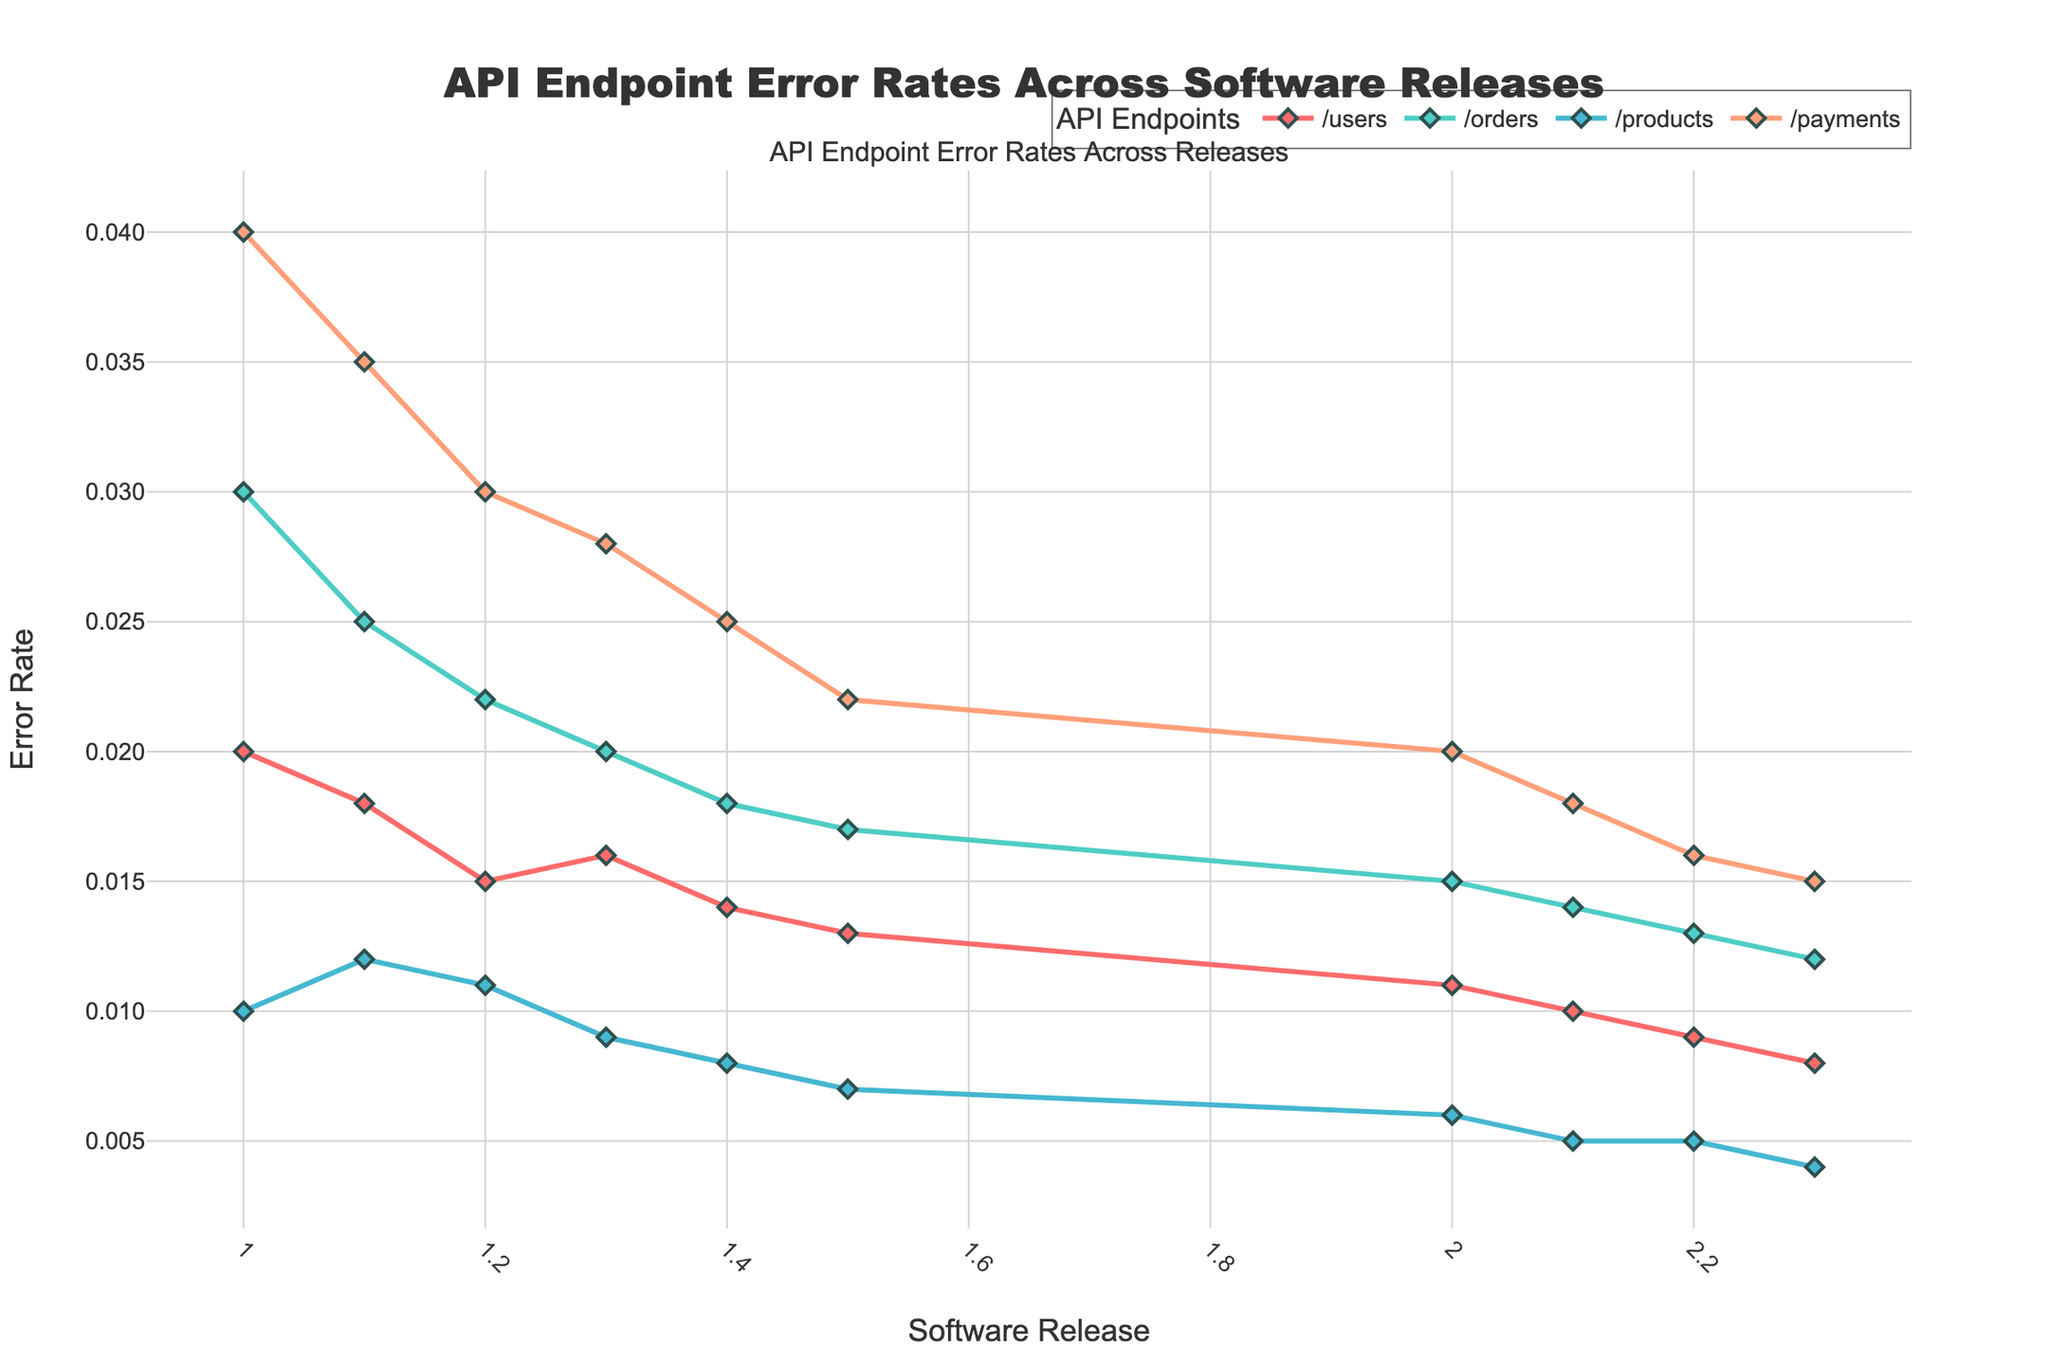Which API endpoint showed the highest error rate in release 1.0? Look at the error rates for /users, /orders, /products, and /payments in release 1.0. The /payments endpoint has the highest error rate of 0.04.
Answer: /payments Which API endpoint has the lowest error rate across all releases? Compare the lowest error rates for each endpoint across releases. The /products endpoint has the minimum error rate of 0.004 in release 2.3.
Answer: /products Between releases 1.0 and 2.3, which API endpoint had the largest decrease in error rate? Compare the error rates for each endpoint in releases 1.0 and 2.3. /payments had an error rate decrease from 0.04 in release 1.0 to 0.015 in release 2.3, a decrease of 0.025.
Answer: /payments In which release did the /orders API endpoint first achieve an error rate of 0.02 or lower? Look at the error rates for the /orders endpoint across all releases. It first achieved an error rate of 0.02 in release 1.3.
Answer: 1.3 How many software releases had an error rate of less than 0.01 for the /products API endpoint? Count the releases where the /products endpoint had an error rate less than 0.01. These are releases 1.4, 1.5, 2.0, 2.1, 2.2, 2.3. Six releases in total.
Answer: 6 What is the average error rate for the /users endpoint across all releases? Sum the error rates for the /users endpoint across all releases and divide by the number of releases: (0.02 + 0.018 + 0.015 + 0.016 + 0.014 + 0.013 + 0.011 + 0.01 + 0.009 + 0.008) / 10 = 0.0134.
Answer: 0.0134 Which release shows the smallest variation in error rates across all API endpoints? Calculate the range (max error rate - min error rate) for each release. Release 2.3 has the smallest range: 0.008 (/users) - 0.004 (/products) = 0.004.
Answer: 2.3 By how much did the error rate of the /orders endpoint improve from release 1.1 to release 2.1? The error rate for the /orders endpoint in release 1.1 is 0.025, and in release 2.1 it is 0.014. The improvement is 0.025 - 0.014 = 0.011.
Answer: 0.011 